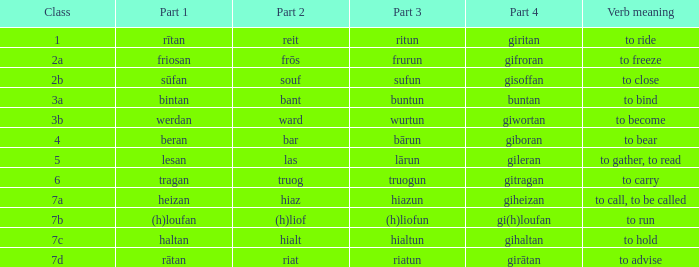What is the part 3 of the word in class 7a? Hiazun. 